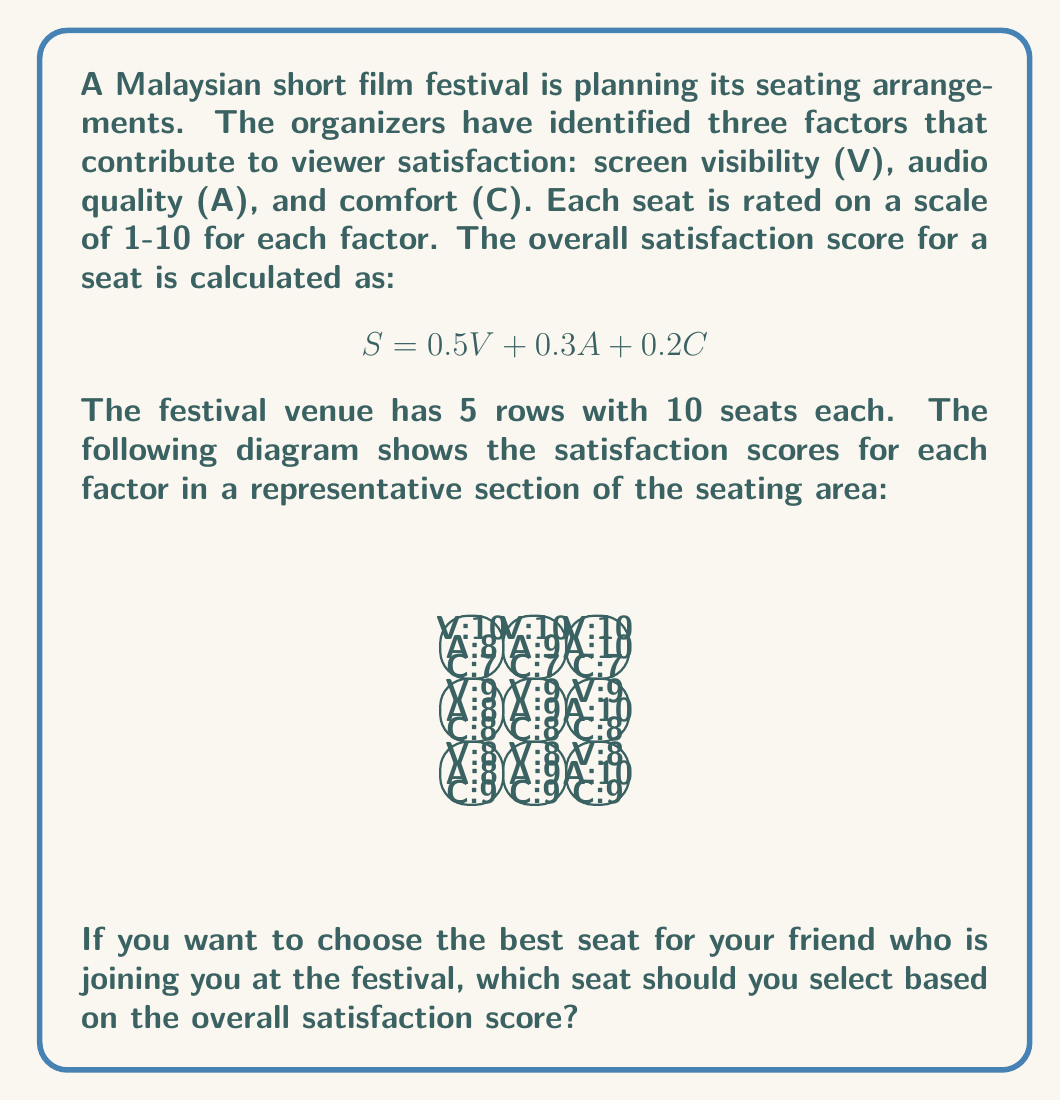Show me your answer to this math problem. To solve this problem, we need to calculate the overall satisfaction score for each seat using the given formula and compare the results. Let's go through this step-by-step:

1. Understand the formula:
   $S = 0.5V + 0.3A + 0.2C$
   Where S is the overall satisfaction score, V is visibility, A is audio quality, and C is comfort.

2. Calculate the score for each seat:

   Front row, left seat:
   $S = 0.5(10) + 0.3(8) + 0.2(7) = 5 + 2.4 + 1.4 = 8.8$

   Front row, middle seat:
   $S = 0.5(10) + 0.3(9) + 0.2(7) = 5 + 2.7 + 1.4 = 9.1$

   Front row, right seat:
   $S = 0.5(10) + 0.3(10) + 0.2(7) = 5 + 3 + 1.4 = 9.4$

   Middle row, left seat:
   $S = 0.5(9) + 0.3(8) + 0.2(8) = 4.5 + 2.4 + 1.6 = 8.5$

   Middle row, middle seat:
   $S = 0.5(9) + 0.3(9) + 0.2(8) = 4.5 + 2.7 + 1.6 = 8.8$

   Middle row, right seat:
   $S = 0.5(9) + 0.3(10) + 0.2(8) = 4.5 + 3 + 1.6 = 9.1$

   Back row, left seat:
   $S = 0.5(8) + 0.3(8) + 0.2(9) = 4 + 2.4 + 1.8 = 8.2$

   Back row, middle seat:
   $S = 0.5(8) + 0.3(9) + 0.2(9) = 4 + 2.7 + 1.8 = 8.5$

   Back row, right seat:
   $S = 0.5(8) + 0.3(10) + 0.2(9) = 4 + 3 + 1.8 = 8.8$

3. Compare the scores:
   The highest score is 9.4, which corresponds to the front row, right seat.

Therefore, you should choose the front row, right seat for your friend to maximize their satisfaction based on the given criteria.
Answer: Front row, right seat 